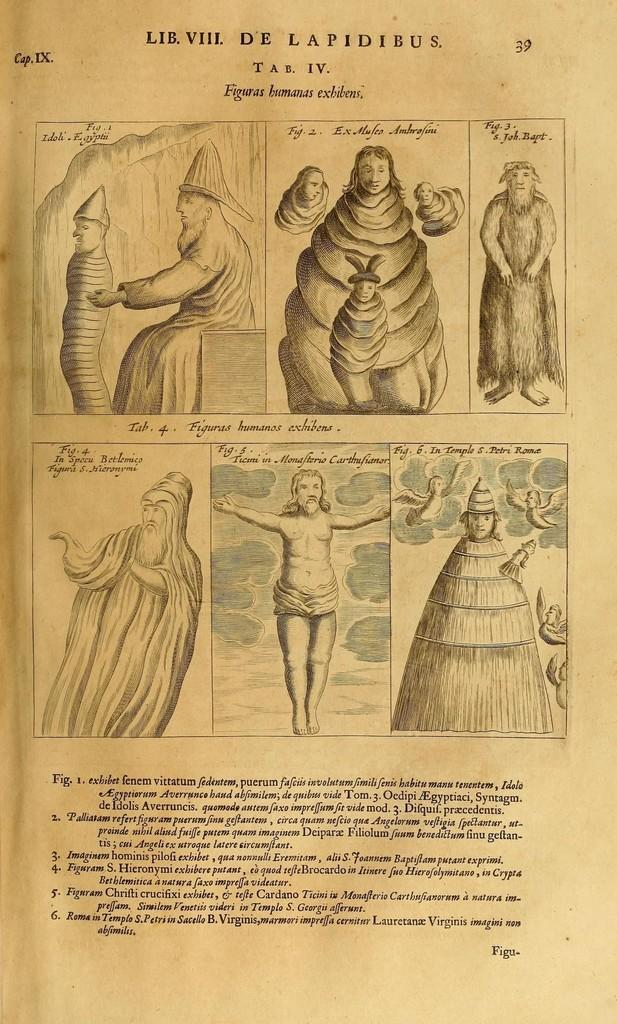What is the main subject of the image? The main subject of the image is a page of a book. What type of content is on the page? The page contains diagrams and text. Can you see a rabbit hopping through the wilderness on the page? No, there is no rabbit or wilderness depicted on the page; it contains diagrams and text. 